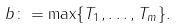Convert formula to latex. <formula><loc_0><loc_0><loc_500><loc_500>b \colon = \max \{ T _ { 1 } , \dots , T _ { m } \} .</formula> 